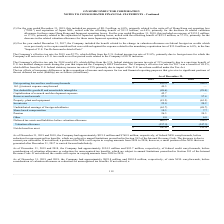According to On Semiconductor's financial document, How much was the foreign credit carryforwards before consideration of valuation allowance as of December 31, 2019? Based on the financial document, the answer is $76.8 million. Also, How much was the foreign credit carryforwards before consideration of valuation allowance as of December 31, 2018? Based on the financial document, the answer is $68.8 million. Also, When does the credits expire if they are not utilized? Based on the financial document, the answer is 2026. Also, can you calculate: What is the change in Net operating loss and tax credit carryforwards from December 31, 2018 to 2019? Based on the calculation: 612.9-584.9, the result is 28 (in millions). This is based on the information: "Net operating loss and tax credit carryforwards $ 612.9 $ 584.9 ating loss and tax credit carryforwards $ 612.9 $ 584.9..." The key data points involved are: 584.9, 612.9. Also, can you calculate: What is the change in Reserves and accruals from year ended December 31, 2018 to 2019? Based on the calculation: 27.5-57.4, the result is -29.9 (in millions). This is based on the information: "Reserves and accruals 27.5 57.4 Reserves and accruals 27.5 57.4..." The key data points involved are: 27.5, 57.4. Also, can you calculate: What is the average Net operating loss and tax credit carryforwards for December 31, 2018 and 2019? To answer this question, I need to perform calculations using the financial data. The calculation is: (612.9+584.9) / 2, which equals 598.9 (in millions). This is based on the information: "Net operating loss and tax credit carryforwards $ 612.9 $ 584.9 ating loss and tax credit carryforwards $ 612.9 $ 584.9..." The key data points involved are: 584.9, 612.9. 